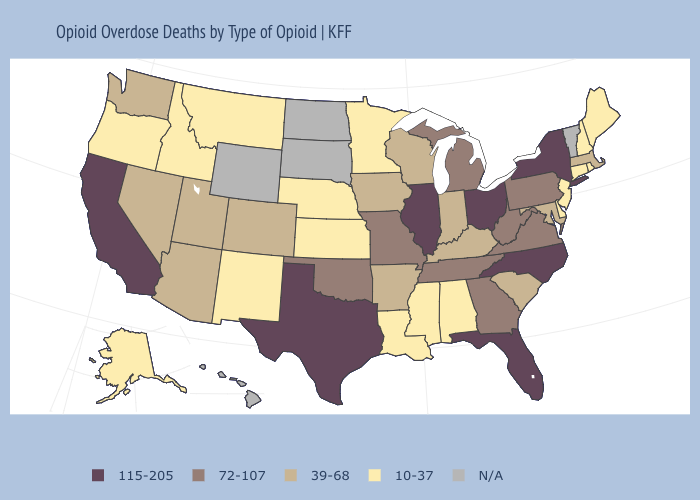Among the states that border California , does Oregon have the lowest value?
Keep it brief. Yes. What is the value of Wisconsin?
Be succinct. 39-68. Which states have the lowest value in the USA?
Answer briefly. Alabama, Alaska, Connecticut, Delaware, Idaho, Kansas, Louisiana, Maine, Minnesota, Mississippi, Montana, Nebraska, New Hampshire, New Jersey, New Mexico, Oregon, Rhode Island. Name the states that have a value in the range 72-107?
Concise answer only. Georgia, Michigan, Missouri, Oklahoma, Pennsylvania, Tennessee, Virginia, West Virginia. What is the lowest value in states that border Ohio?
Be succinct. 39-68. Which states have the lowest value in the Northeast?
Write a very short answer. Connecticut, Maine, New Hampshire, New Jersey, Rhode Island. Among the states that border Wisconsin , does Iowa have the highest value?
Give a very brief answer. No. What is the value of South Dakota?
Give a very brief answer. N/A. What is the highest value in the USA?
Keep it brief. 115-205. Name the states that have a value in the range 115-205?
Keep it brief. California, Florida, Illinois, New York, North Carolina, Ohio, Texas. What is the lowest value in the West?
Write a very short answer. 10-37. Name the states that have a value in the range 72-107?
Be succinct. Georgia, Michigan, Missouri, Oklahoma, Pennsylvania, Tennessee, Virginia, West Virginia. What is the value of Tennessee?
Short answer required. 72-107. 